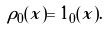<formula> <loc_0><loc_0><loc_500><loc_500>\rho _ { 0 } ( x ) = 1 _ { 0 } ( x ) .</formula> 